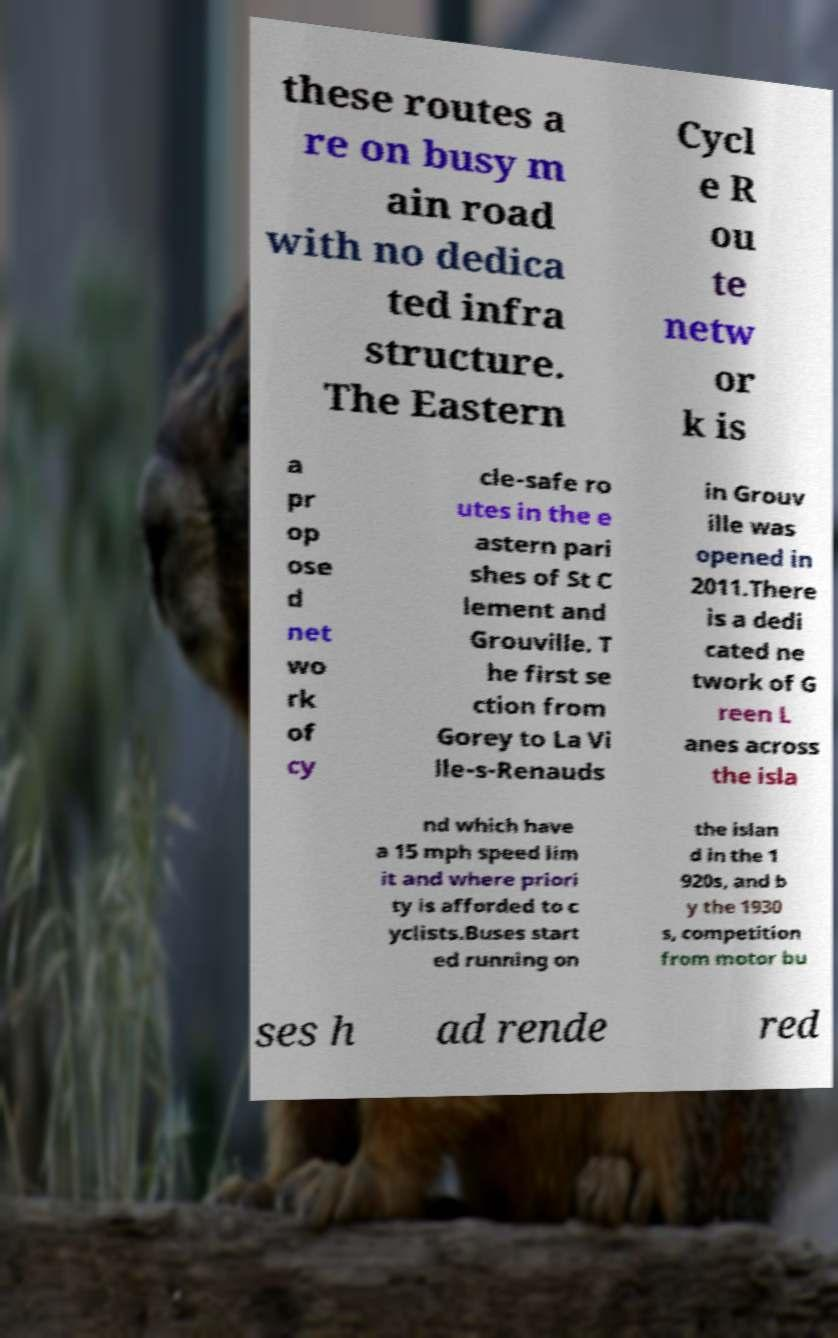Please identify and transcribe the text found in this image. these routes a re on busy m ain road with no dedica ted infra structure. The Eastern Cycl e R ou te netw or k is a pr op ose d net wo rk of cy cle-safe ro utes in the e astern pari shes of St C lement and Grouville. T he first se ction from Gorey to La Vi lle-s-Renauds in Grouv ille was opened in 2011.There is a dedi cated ne twork of G reen L anes across the isla nd which have a 15 mph speed lim it and where priori ty is afforded to c yclists.Buses start ed running on the islan d in the 1 920s, and b y the 1930 s, competition from motor bu ses h ad rende red 